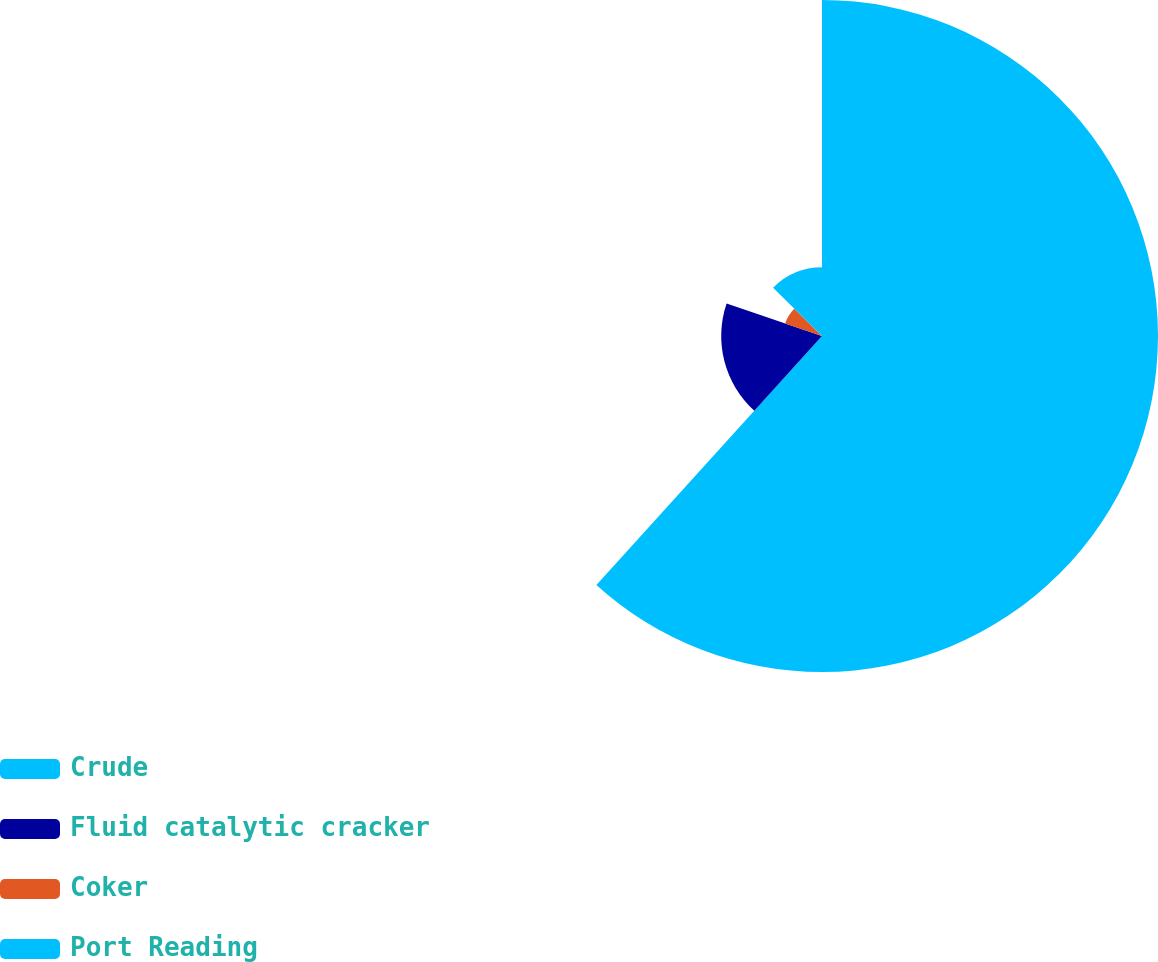Convert chart to OTSL. <chart><loc_0><loc_0><loc_500><loc_500><pie_chart><fcel>Crude<fcel>Fluid catalytic cracker<fcel>Coker<fcel>Port Reading<nl><fcel>61.71%<fcel>18.51%<fcel>7.16%<fcel>12.61%<nl></chart> 